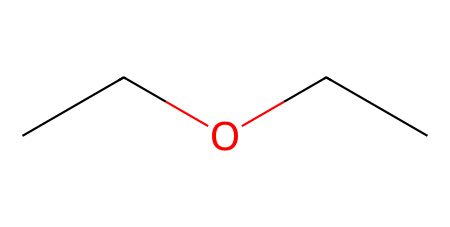What is the name of this chemical? The structure represented by the SMILES notation "CCOCC" corresponds to diethyl ether, which is a common ether used as a solvent.
Answer: diethyl ether How many carbon atoms are there in this chemical? Analyzing the SMILES, there are four carbon atoms present (two from each ethyl group).
Answer: four What type of functional group is present in diethyl ether? The presence of the oxygen atom bridging the two carbon chains indicates that this compound contains an ether functional group.
Answer: ether What is the total number of hydrogen atoms in diethyl ether? Each carbon in ethyl contributes three hydrogen atoms, and since there are four carbon atoms, the total number of hydrogen atoms is 10, calculated as (4 carbons x 3 hydrogens) - 2 from the ether linkage.
Answer: ten What is the molecular formula for diethyl ether based on the structure? The molecular formula is derived by combining the number of carbon, hydrogen, and oxygen atoms represented in the structure: C4H10O.
Answer: C4H10O Does diethyl ether have a polar or nonpolar characteristic? The presence of the polar ether oxygen tends towards a polar nature; however, the overall structure with long carbon chains contributes to it being relatively nonpolar.
Answer: nonpolar 